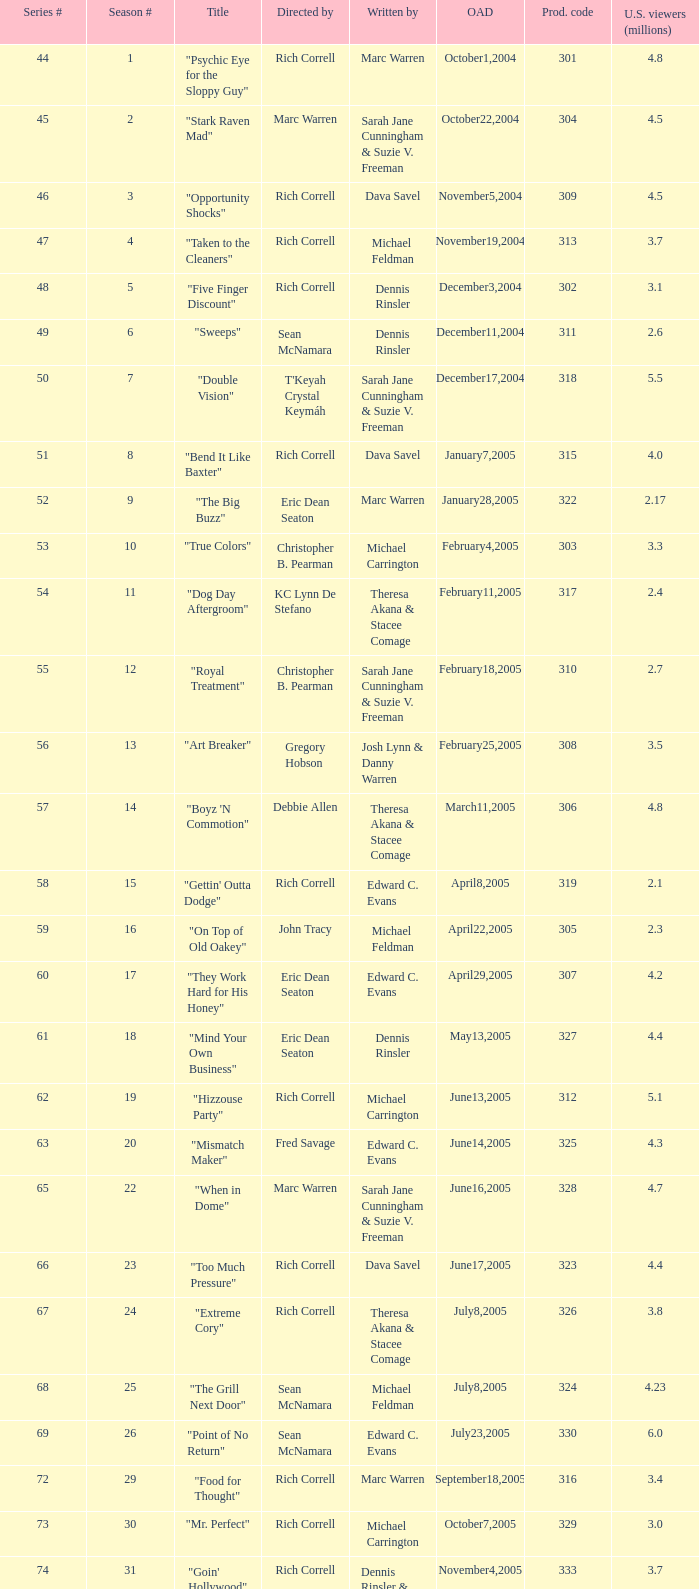What was the production code of the episode directed by Rondell Sheridan?  332.0. 